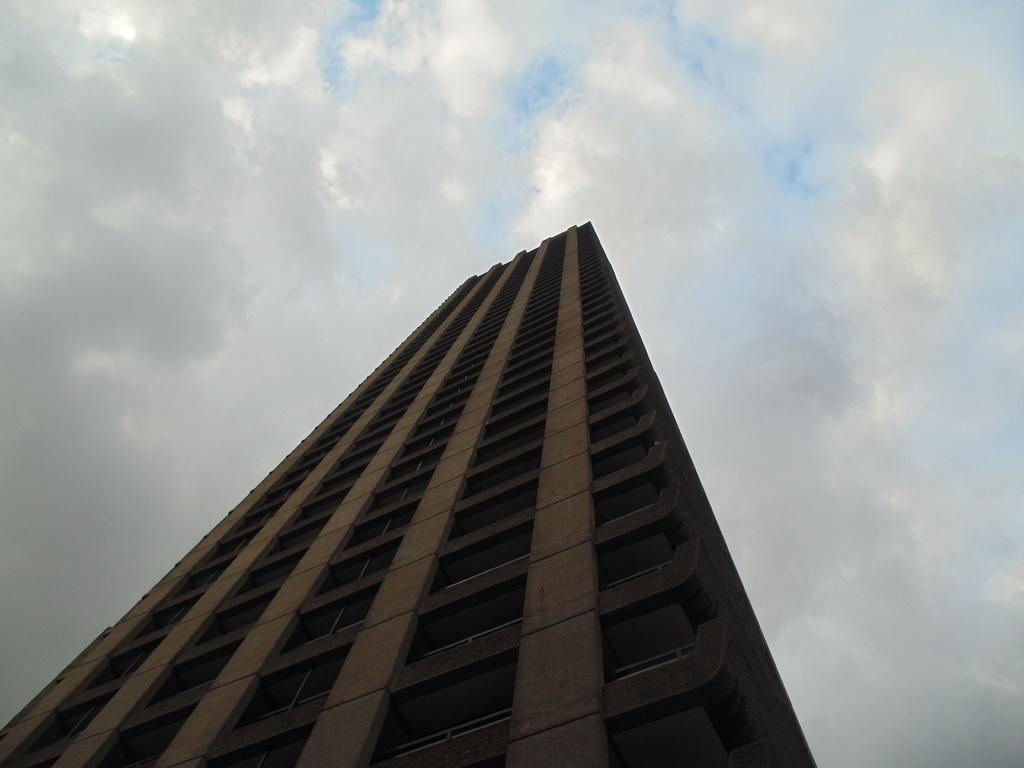What type of structure is present in the image? There is a building in the image. What is the color of the building? The building is brown in color. Are there any specific features on the building? Yes, there are windows on the building. What is the color of the windows? The windows are black in color. What can be seen in the background of the image? The sky is visible in the background of the image. What type of net is being used to catch the quiver in the image? There is no net or quiver present in the image; it features a brown building with black windows. 